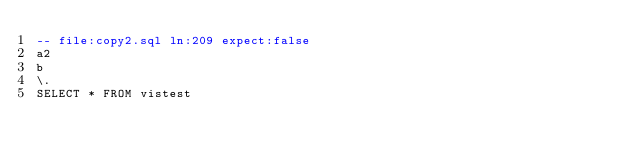<code> <loc_0><loc_0><loc_500><loc_500><_SQL_>-- file:copy2.sql ln:209 expect:false
a2
b
\.
SELECT * FROM vistest
</code> 